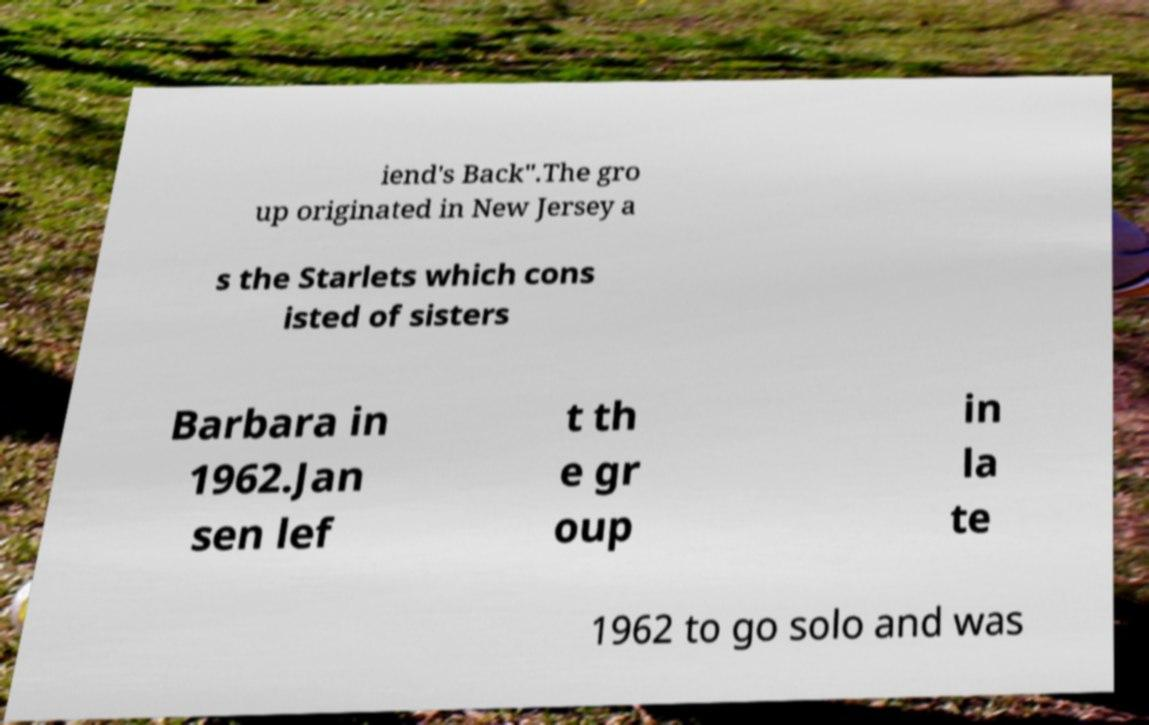What messages or text are displayed in this image? I need them in a readable, typed format. iend's Back".The gro up originated in New Jersey a s the Starlets which cons isted of sisters Barbara in 1962.Jan sen lef t th e gr oup in la te 1962 to go solo and was 